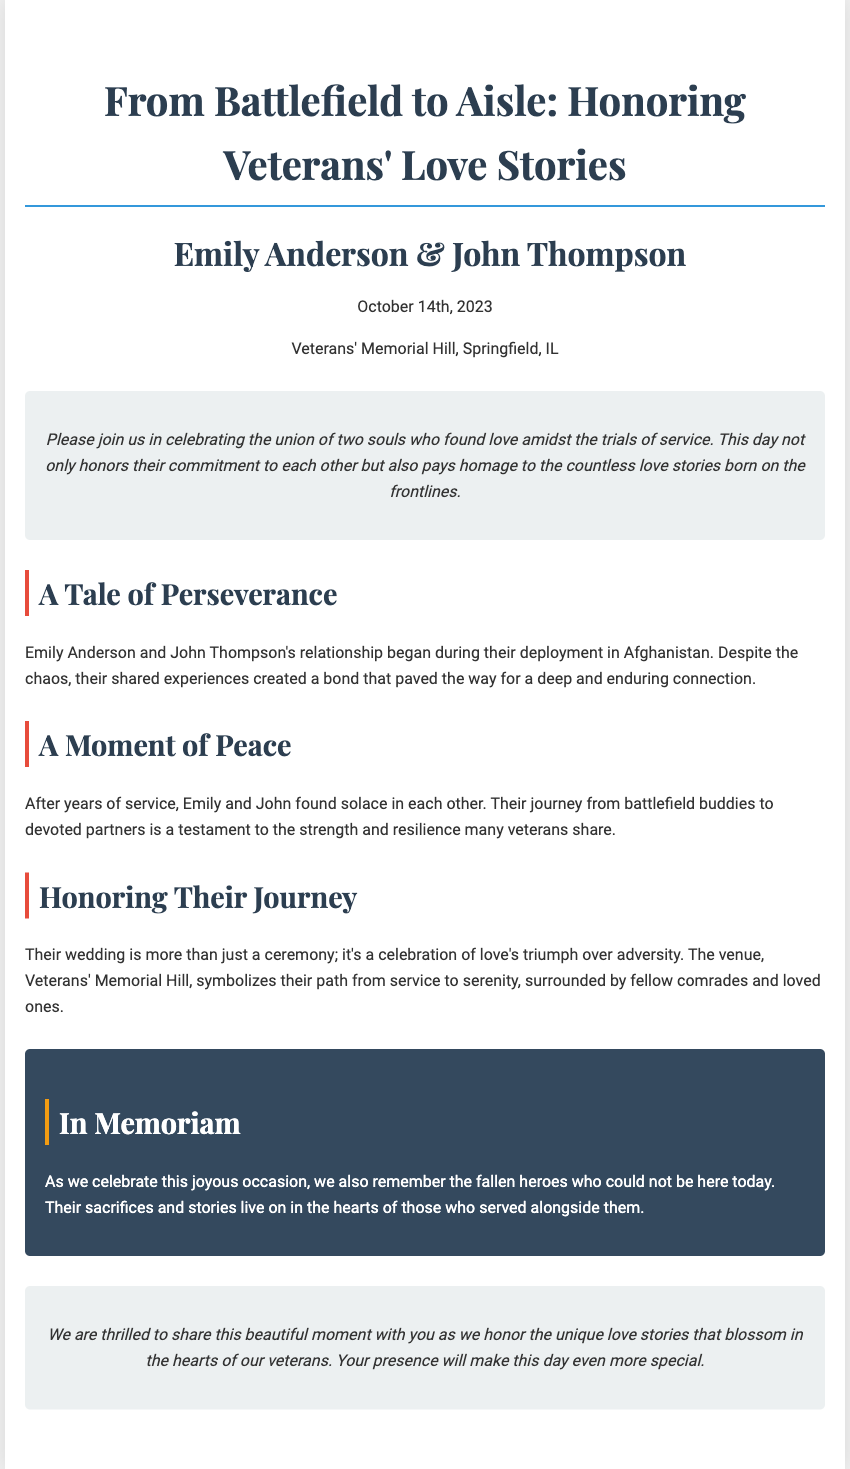What are the names of the couple? The names of the couple are Emily Anderson and John Thompson as stated in the header.
Answer: Emily Anderson & John Thompson What is the date of the wedding? The date of the wedding is mentioned in the header of the document.
Answer: October 14th, 2023 Where is the venue located? The venue is specified in the header as the location of the wedding.
Answer: Veterans' Memorial Hill, Springfield, IL What is the theme of the wedding? The theme is indicated in the title of the invitation.
Answer: Honoring Veterans' Love Stories What does the wedding symbolize? The wedding symbolizes a transition from service to a peaceful life, as described in the "Honoring Their Journey" section.
Answer: A celebration of love's triumph over adversity How did Emily and John meet? Their meeting context is provided in the "A Tale of Perseverance" section.
Answer: During their deployment in Afghanistan What do the couple want to convey through their wedding? The couple aims to honor the unique love stories of veterans, as expressed in the closing remarks.
Answer: Celebrate unique love stories What is mentioned in the "In Memoriam" section? This section commemorates the fallen heroes who couldn't attend the wedding.
Answer: Remember the fallen heroes What kind of story does Emily and John's journey represent? The journey illustrates resilience, as mentioned in the "A Moment of Peace" section.
Answer: Strength and resilience 